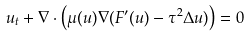<formula> <loc_0><loc_0><loc_500><loc_500>u _ { t } + \nabla \cdot \left ( \mu ( u ) \nabla ( F ^ { \prime } ( u ) - \tau ^ { 2 } \Delta u ) \right ) = 0</formula> 